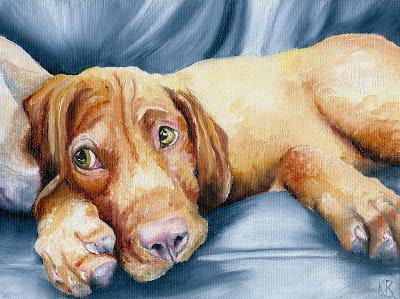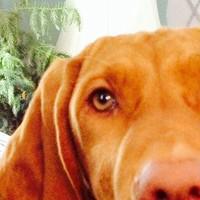The first image is the image on the left, the second image is the image on the right. Examine the images to the left and right. Is the description "The dog in the image on the left is lying down on a blue material." accurate? Answer yes or no. Yes. The first image is the image on the left, the second image is the image on the right. Considering the images on both sides, is "The left and right image contains the same number of dogs and at least one is a puppy." valid? Answer yes or no. No. 